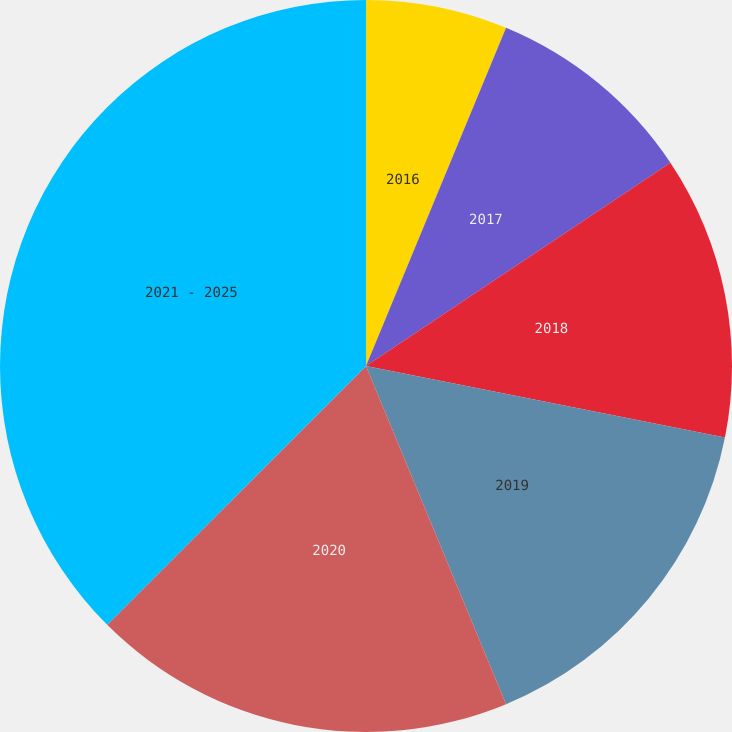<chart> <loc_0><loc_0><loc_500><loc_500><pie_chart><fcel>2016<fcel>2017<fcel>2018<fcel>2019<fcel>2020<fcel>2021 - 2025<nl><fcel>6.25%<fcel>9.38%<fcel>12.5%<fcel>15.62%<fcel>18.75%<fcel>37.5%<nl></chart> 